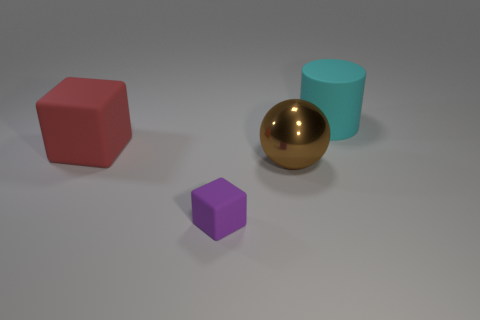Add 4 large green matte cubes. How many objects exist? 8 Subtract all red cubes. How many cubes are left? 1 Subtract all balls. How many objects are left? 3 Subtract 1 balls. How many balls are left? 0 Subtract all yellow cubes. Subtract all gray cylinders. How many cubes are left? 2 Subtract all yellow cylinders. How many red blocks are left? 1 Subtract all rubber blocks. Subtract all big brown spheres. How many objects are left? 1 Add 3 large things. How many large things are left? 6 Add 1 brown rubber cylinders. How many brown rubber cylinders exist? 1 Subtract 0 gray cylinders. How many objects are left? 4 